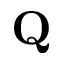Convert formula to latex. <formula><loc_0><loc_0><loc_500><loc_500>Q</formula> 